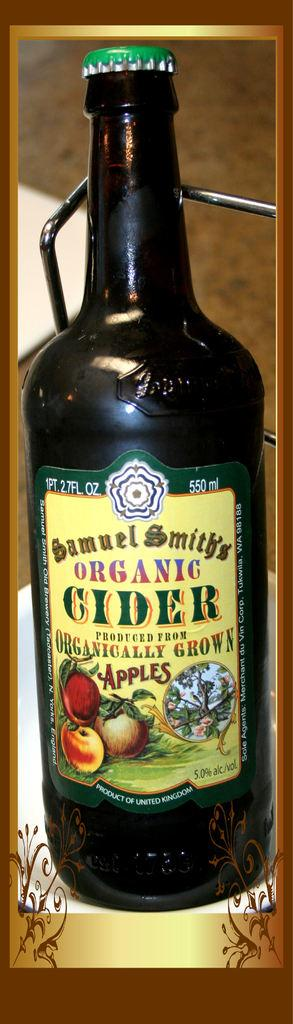Provide a one-sentence caption for the provided image. a green bottle of Samuel Smith's Organic Cider 550 ml. 